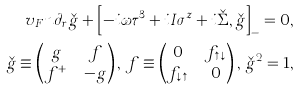<formula> <loc_0><loc_0><loc_500><loc_500>v _ { F } n \partial _ { r } \check { g } + \left [ - i \omega \tau ^ { 3 } + i I \sigma ^ { z } + i \check { \Sigma } , \check { g } \right ] _ { - } = 0 , \\ \check { g } \equiv \begin{pmatrix} g & f \\ f ^ { + } & - g \end{pmatrix} , \, f \equiv \begin{pmatrix} 0 & f _ { \uparrow \downarrow } \\ f _ { \downarrow \uparrow } & 0 \end{pmatrix} , \, \check { g } ^ { 2 } = 1 ,</formula> 